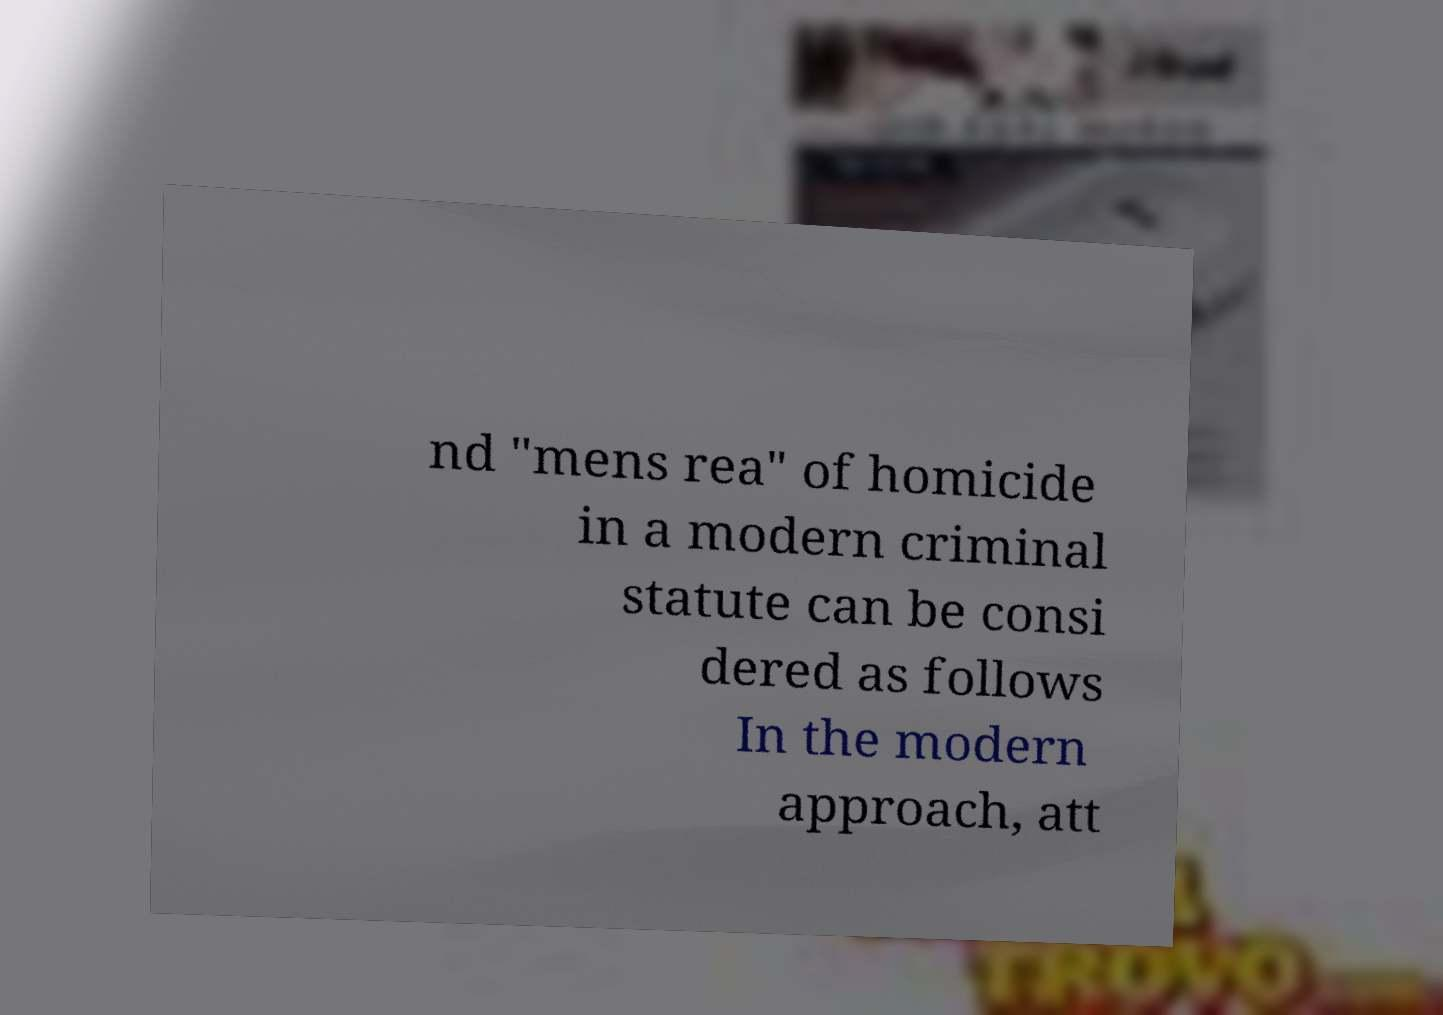Can you accurately transcribe the text from the provided image for me? nd "mens rea" of homicide in a modern criminal statute can be consi dered as follows In the modern approach, att 